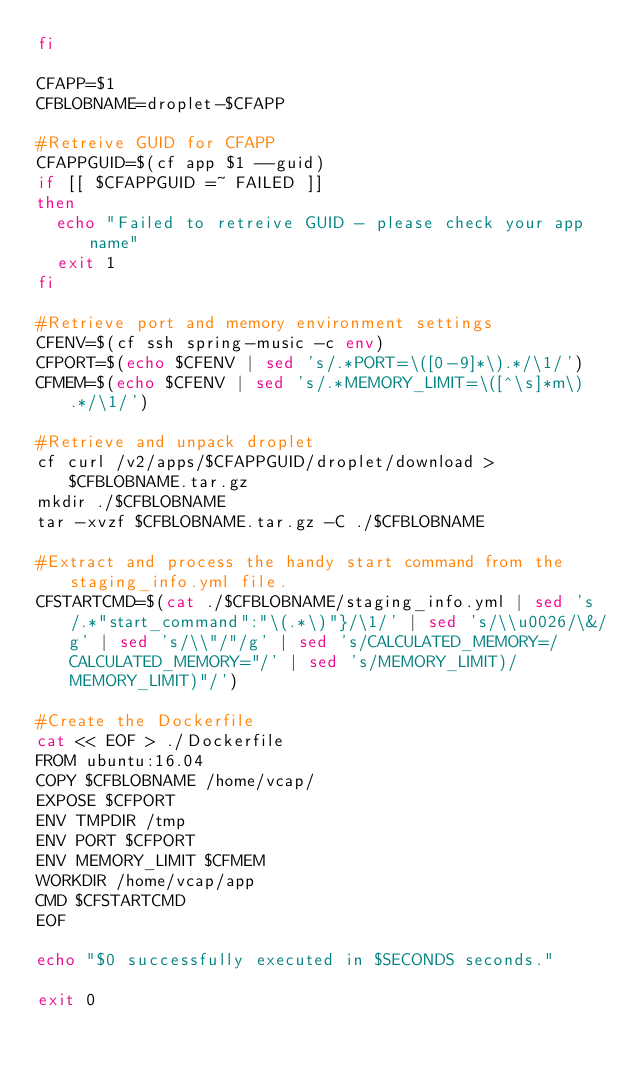Convert code to text. <code><loc_0><loc_0><loc_500><loc_500><_Bash_>fi

CFAPP=$1
CFBLOBNAME=droplet-$CFAPP

#Retreive GUID for CFAPP
CFAPPGUID=$(cf app $1 --guid)
if [[ $CFAPPGUID =~ FAILED ]]
then
	echo "Failed to retreive GUID - please check your app name"
	exit 1
fi

#Retrieve port and memory environment settings
CFENV=$(cf ssh spring-music -c env)
CFPORT=$(echo $CFENV | sed 's/.*PORT=\([0-9]*\).*/\1/')
CFMEM=$(echo $CFENV | sed 's/.*MEMORY_LIMIT=\([^\s]*m\).*/\1/')

#Retrieve and unpack droplet
cf curl /v2/apps/$CFAPPGUID/droplet/download > $CFBLOBNAME.tar.gz
mkdir ./$CFBLOBNAME
tar -xvzf $CFBLOBNAME.tar.gz -C ./$CFBLOBNAME

#Extract and process the handy start command from the staging_info.yml file.
CFSTARTCMD=$(cat ./$CFBLOBNAME/staging_info.yml | sed 's/.*"start_command":"\(.*\)"}/\1/' | sed 's/\\u0026/\&/g' | sed 's/\\"/"/g' | sed 's/CALCULATED_MEMORY=/CALCULATED_MEMORY="/' | sed 's/MEMORY_LIMIT)/MEMORY_LIMIT)"/')

#Create the Dockerfile
cat << EOF > ./Dockerfile
FROM ubuntu:16.04
COPY $CFBLOBNAME /home/vcap/
EXPOSE $CFPORT
ENV TMPDIR /tmp
ENV PORT $CFPORT
ENV MEMORY_LIMIT $CFMEM
WORKDIR /home/vcap/app
CMD $CFSTARTCMD
EOF

echo "$0 successfully executed in $SECONDS seconds."

exit 0
</code> 